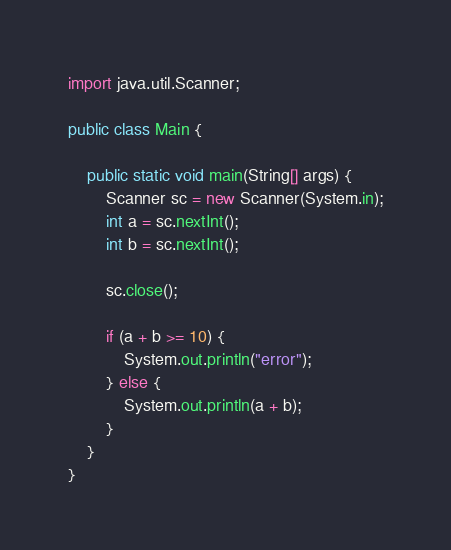<code> <loc_0><loc_0><loc_500><loc_500><_Java_>import java.util.Scanner;

public class Main {

    public static void main(String[] args) {
        Scanner sc = new Scanner(System.in);
        int a = sc.nextInt();
        int b = sc.nextInt();

        sc.close();

        if (a + b >= 10) {
            System.out.println("error");
        } else {
            System.out.println(a + b);
        }
    }
}</code> 